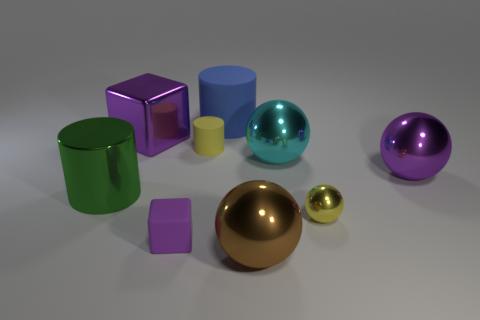Subtract all big cylinders. How many cylinders are left? 1 Subtract all blue cylinders. How many cylinders are left? 2 Subtract 1 cylinders. How many cylinders are left? 2 Add 4 big brown metal balls. How many big brown metal balls exist? 5 Subtract 1 brown spheres. How many objects are left? 8 Subtract all cylinders. How many objects are left? 6 Subtract all brown balls. Subtract all brown blocks. How many balls are left? 3 Subtract all blue spheres. How many brown cubes are left? 0 Subtract all small matte things. Subtract all big metallic cylinders. How many objects are left? 6 Add 6 shiny cylinders. How many shiny cylinders are left? 7 